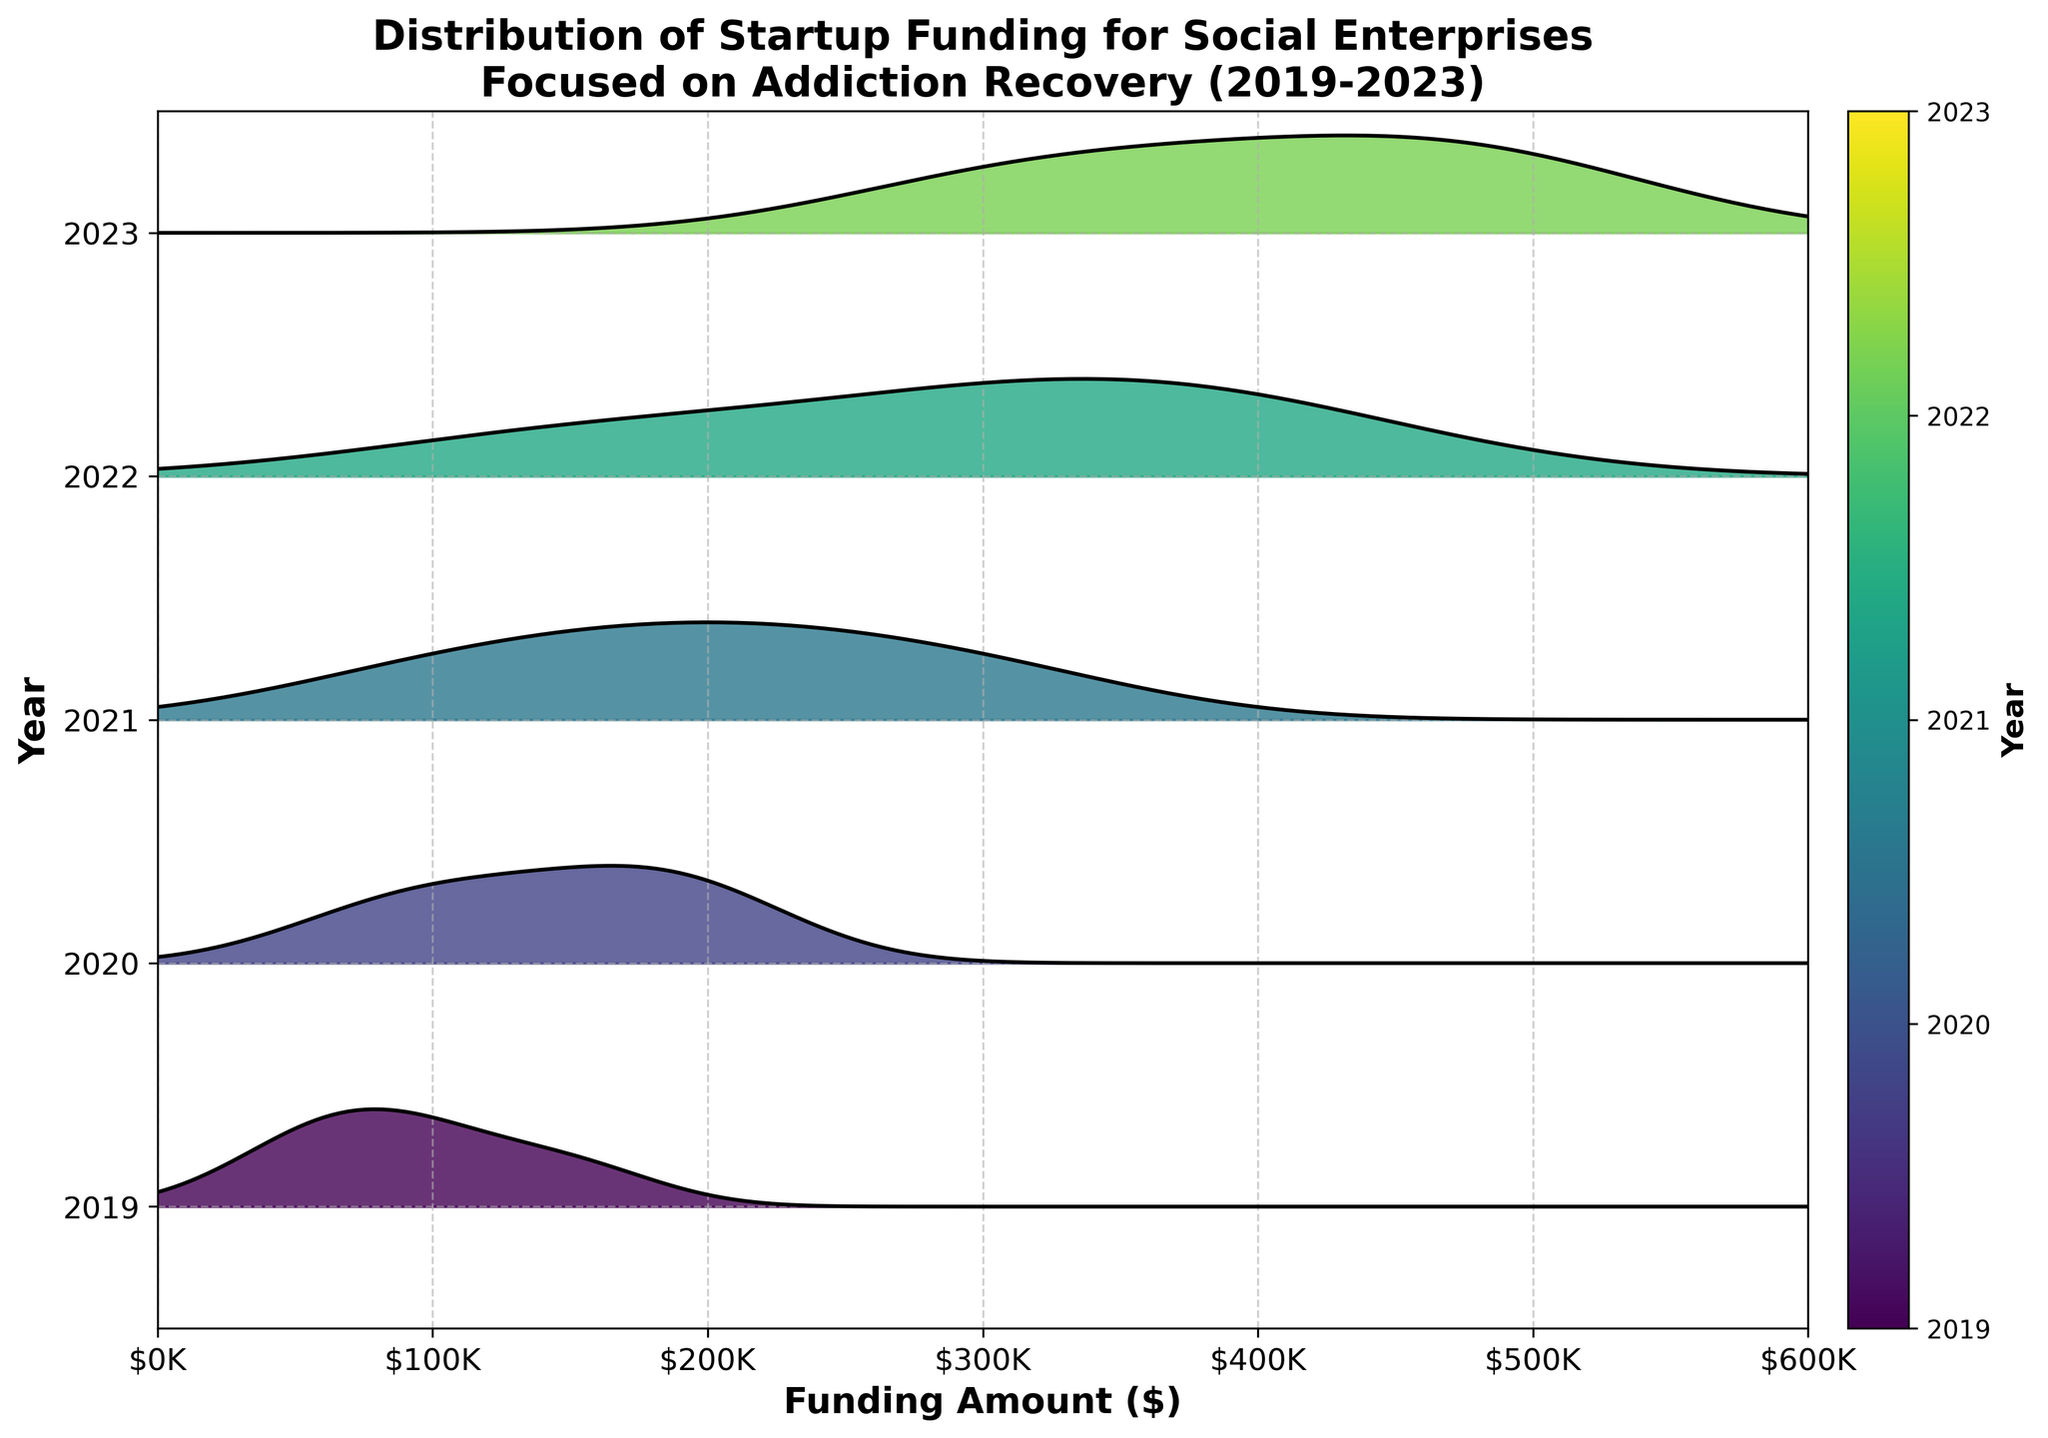Which year has the highest funding amount? In the ridgeline plot, the year 2023 has the highest peak, indicating the highest funding amount.
Answer: 2023 What is the approximate range of funding amounts in 2019? The range of funding amounts in 2019 appears to span from about $50,000 to $150,000, as indicated by the x-axis values corresponding to the filled area for that year.
Answer: $50,000 to $150,000 How does the funding distribution in 2020 compare to that in 2021? The funding distribution in 2020 has a lower overall range and peaks compared to 2021. The peak in 2020 is closer to $175,000, while the peak in 2021 is higher, around $300,000.
Answer: 2020 has lower peaks and range compared to 2021 Which year shows the most variability in funding amounts? 2022 shows the most variability, spanning from about $150,000 to $400,000, as indicated by the wider spread of the filled area.
Answer: 2022 In which year is the funding amount most concentrated around a single value? The year 2019 shows the most concentration around a narrower range, with most funding amounts around $50,000 to $150,000.
Answer: 2019 What is the median funding amount range in 2023? The majority of the funding amounts in 2023 appear to be concentrated around the middle range of $300,000 to $450,000.
Answer: $300,000 to $450,000 Is the funding trend increasing, decreasing, or staying the same over the years? The funding trend appears to be increasing over the years, as evident from the higher funding peaks and wider ranges in 2022 and 2023.
Answer: Increasing How does the funding amount in 2021 compare to 2019? The funding amount in 2021 is generally higher and more spread out compared to 2019, with the 2021 peak around $225,000 to $300,000 whereas 2019 peaks around $50,000 to $150,000.
Answer: Higher and more spread out Which year has the smallest spread in funding amounts? The year 2019 has the smallest spread, with funding amounts ranging roughly from $50,000 to $150,000.
Answer: 2019 